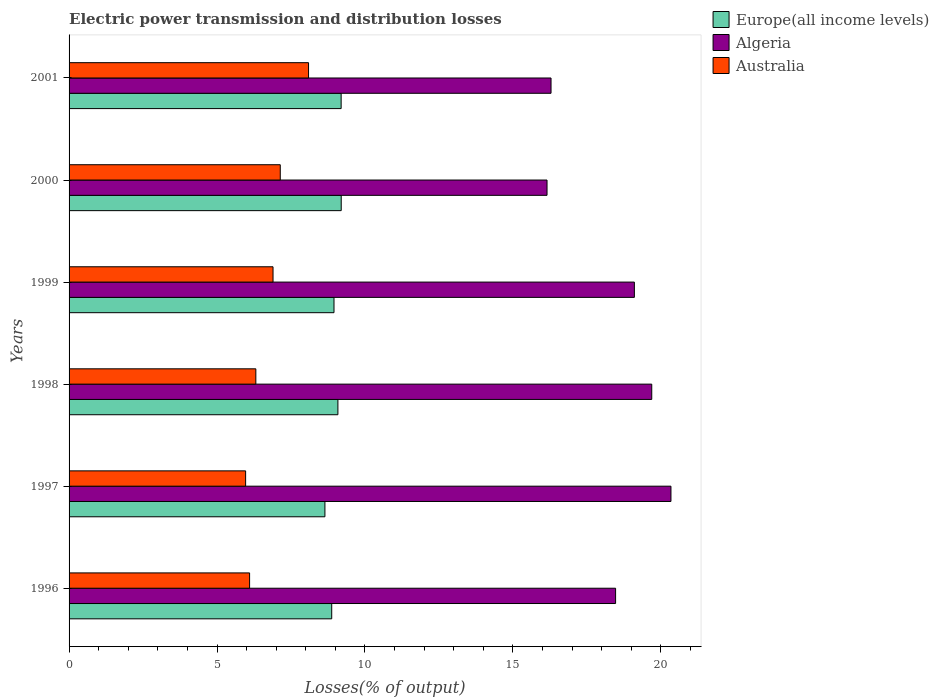How many groups of bars are there?
Make the answer very short. 6. Are the number of bars on each tick of the Y-axis equal?
Offer a terse response. Yes. In how many cases, is the number of bars for a given year not equal to the number of legend labels?
Ensure brevity in your answer.  0. What is the electric power transmission and distribution losses in Algeria in 1997?
Keep it short and to the point. 20.34. Across all years, what is the maximum electric power transmission and distribution losses in Australia?
Your answer should be very brief. 8.09. Across all years, what is the minimum electric power transmission and distribution losses in Australia?
Offer a terse response. 5.97. In which year was the electric power transmission and distribution losses in Algeria minimum?
Your answer should be compact. 2000. What is the total electric power transmission and distribution losses in Australia in the graph?
Ensure brevity in your answer.  40.51. What is the difference between the electric power transmission and distribution losses in Algeria in 1996 and that in 1998?
Give a very brief answer. -1.22. What is the difference between the electric power transmission and distribution losses in Europe(all income levels) in 1997 and the electric power transmission and distribution losses in Australia in 1999?
Your response must be concise. 1.75. What is the average electric power transmission and distribution losses in Europe(all income levels) per year?
Your response must be concise. 8.99. In the year 2000, what is the difference between the electric power transmission and distribution losses in Algeria and electric power transmission and distribution losses in Europe(all income levels)?
Ensure brevity in your answer.  6.96. What is the ratio of the electric power transmission and distribution losses in Algeria in 1998 to that in 2000?
Offer a terse response. 1.22. Is the electric power transmission and distribution losses in Australia in 1997 less than that in 2001?
Make the answer very short. Yes. What is the difference between the highest and the second highest electric power transmission and distribution losses in Algeria?
Your response must be concise. 0.65. What is the difference between the highest and the lowest electric power transmission and distribution losses in Australia?
Your response must be concise. 2.13. In how many years, is the electric power transmission and distribution losses in Europe(all income levels) greater than the average electric power transmission and distribution losses in Europe(all income levels) taken over all years?
Offer a terse response. 3. Is the sum of the electric power transmission and distribution losses in Europe(all income levels) in 1998 and 2001 greater than the maximum electric power transmission and distribution losses in Australia across all years?
Keep it short and to the point. Yes. What does the 1st bar from the top in 1999 represents?
Your response must be concise. Australia. What does the 1st bar from the bottom in 1999 represents?
Keep it short and to the point. Europe(all income levels). Is it the case that in every year, the sum of the electric power transmission and distribution losses in Algeria and electric power transmission and distribution losses in Australia is greater than the electric power transmission and distribution losses in Europe(all income levels)?
Make the answer very short. Yes. How many years are there in the graph?
Ensure brevity in your answer.  6. Does the graph contain grids?
Keep it short and to the point. No. Where does the legend appear in the graph?
Give a very brief answer. Top right. How many legend labels are there?
Keep it short and to the point. 3. How are the legend labels stacked?
Make the answer very short. Vertical. What is the title of the graph?
Offer a terse response. Electric power transmission and distribution losses. What is the label or title of the X-axis?
Ensure brevity in your answer.  Losses(% of output). What is the label or title of the Y-axis?
Your answer should be very brief. Years. What is the Losses(% of output) of Europe(all income levels) in 1996?
Make the answer very short. 8.88. What is the Losses(% of output) of Algeria in 1996?
Ensure brevity in your answer.  18.47. What is the Losses(% of output) in Australia in 1996?
Your answer should be very brief. 6.1. What is the Losses(% of output) in Europe(all income levels) in 1997?
Offer a very short reply. 8.65. What is the Losses(% of output) of Algeria in 1997?
Keep it short and to the point. 20.34. What is the Losses(% of output) in Australia in 1997?
Keep it short and to the point. 5.97. What is the Losses(% of output) of Europe(all income levels) in 1998?
Ensure brevity in your answer.  9.09. What is the Losses(% of output) of Algeria in 1998?
Keep it short and to the point. 19.69. What is the Losses(% of output) in Australia in 1998?
Provide a short and direct response. 6.31. What is the Losses(% of output) of Europe(all income levels) in 1999?
Make the answer very short. 8.95. What is the Losses(% of output) in Algeria in 1999?
Your response must be concise. 19.11. What is the Losses(% of output) in Australia in 1999?
Give a very brief answer. 6.89. What is the Losses(% of output) of Europe(all income levels) in 2000?
Give a very brief answer. 9.2. What is the Losses(% of output) in Algeria in 2000?
Offer a very short reply. 16.15. What is the Losses(% of output) of Australia in 2000?
Your answer should be compact. 7.14. What is the Losses(% of output) in Europe(all income levels) in 2001?
Offer a very short reply. 9.2. What is the Losses(% of output) in Algeria in 2001?
Keep it short and to the point. 16.29. What is the Losses(% of output) of Australia in 2001?
Your answer should be very brief. 8.09. Across all years, what is the maximum Losses(% of output) in Europe(all income levels)?
Your answer should be compact. 9.2. Across all years, what is the maximum Losses(% of output) of Algeria?
Offer a terse response. 20.34. Across all years, what is the maximum Losses(% of output) of Australia?
Provide a succinct answer. 8.09. Across all years, what is the minimum Losses(% of output) of Europe(all income levels)?
Your answer should be compact. 8.65. Across all years, what is the minimum Losses(% of output) of Algeria?
Make the answer very short. 16.15. Across all years, what is the minimum Losses(% of output) of Australia?
Your answer should be very brief. 5.97. What is the total Losses(% of output) in Europe(all income levels) in the graph?
Offer a very short reply. 53.96. What is the total Losses(% of output) of Algeria in the graph?
Offer a very short reply. 110.06. What is the total Losses(% of output) in Australia in the graph?
Keep it short and to the point. 40.51. What is the difference between the Losses(% of output) of Europe(all income levels) in 1996 and that in 1997?
Your answer should be very brief. 0.23. What is the difference between the Losses(% of output) in Algeria in 1996 and that in 1997?
Provide a short and direct response. -1.87. What is the difference between the Losses(% of output) of Australia in 1996 and that in 1997?
Your answer should be very brief. 0.13. What is the difference between the Losses(% of output) in Europe(all income levels) in 1996 and that in 1998?
Offer a very short reply. -0.21. What is the difference between the Losses(% of output) of Algeria in 1996 and that in 1998?
Your answer should be compact. -1.22. What is the difference between the Losses(% of output) in Australia in 1996 and that in 1998?
Offer a terse response. -0.21. What is the difference between the Losses(% of output) in Europe(all income levels) in 1996 and that in 1999?
Offer a very short reply. -0.08. What is the difference between the Losses(% of output) of Algeria in 1996 and that in 1999?
Offer a terse response. -0.63. What is the difference between the Losses(% of output) of Australia in 1996 and that in 1999?
Give a very brief answer. -0.79. What is the difference between the Losses(% of output) of Europe(all income levels) in 1996 and that in 2000?
Your answer should be compact. -0.32. What is the difference between the Losses(% of output) in Algeria in 1996 and that in 2000?
Your response must be concise. 2.32. What is the difference between the Losses(% of output) in Australia in 1996 and that in 2000?
Your answer should be very brief. -1.04. What is the difference between the Losses(% of output) in Europe(all income levels) in 1996 and that in 2001?
Your answer should be very brief. -0.32. What is the difference between the Losses(% of output) of Algeria in 1996 and that in 2001?
Offer a terse response. 2.18. What is the difference between the Losses(% of output) in Australia in 1996 and that in 2001?
Make the answer very short. -1.99. What is the difference between the Losses(% of output) in Europe(all income levels) in 1997 and that in 1998?
Your response must be concise. -0.44. What is the difference between the Losses(% of output) in Algeria in 1997 and that in 1998?
Ensure brevity in your answer.  0.65. What is the difference between the Losses(% of output) in Australia in 1997 and that in 1998?
Give a very brief answer. -0.35. What is the difference between the Losses(% of output) in Europe(all income levels) in 1997 and that in 1999?
Provide a short and direct response. -0.31. What is the difference between the Losses(% of output) in Algeria in 1997 and that in 1999?
Make the answer very short. 1.24. What is the difference between the Losses(% of output) in Australia in 1997 and that in 1999?
Offer a very short reply. -0.93. What is the difference between the Losses(% of output) in Europe(all income levels) in 1997 and that in 2000?
Provide a short and direct response. -0.55. What is the difference between the Losses(% of output) in Algeria in 1997 and that in 2000?
Your answer should be very brief. 4.19. What is the difference between the Losses(% of output) of Australia in 1997 and that in 2000?
Give a very brief answer. -1.17. What is the difference between the Losses(% of output) in Europe(all income levels) in 1997 and that in 2001?
Offer a terse response. -0.55. What is the difference between the Losses(% of output) of Algeria in 1997 and that in 2001?
Give a very brief answer. 4.05. What is the difference between the Losses(% of output) of Australia in 1997 and that in 2001?
Offer a very short reply. -2.13. What is the difference between the Losses(% of output) in Europe(all income levels) in 1998 and that in 1999?
Offer a terse response. 0.13. What is the difference between the Losses(% of output) of Algeria in 1998 and that in 1999?
Ensure brevity in your answer.  0.59. What is the difference between the Losses(% of output) in Australia in 1998 and that in 1999?
Give a very brief answer. -0.58. What is the difference between the Losses(% of output) in Europe(all income levels) in 1998 and that in 2000?
Provide a short and direct response. -0.11. What is the difference between the Losses(% of output) in Algeria in 1998 and that in 2000?
Your answer should be compact. 3.54. What is the difference between the Losses(% of output) of Australia in 1998 and that in 2000?
Ensure brevity in your answer.  -0.83. What is the difference between the Losses(% of output) of Europe(all income levels) in 1998 and that in 2001?
Provide a short and direct response. -0.11. What is the difference between the Losses(% of output) in Algeria in 1998 and that in 2001?
Give a very brief answer. 3.4. What is the difference between the Losses(% of output) in Australia in 1998 and that in 2001?
Provide a succinct answer. -1.78. What is the difference between the Losses(% of output) of Europe(all income levels) in 1999 and that in 2000?
Your answer should be compact. -0.24. What is the difference between the Losses(% of output) in Algeria in 1999 and that in 2000?
Make the answer very short. 2.95. What is the difference between the Losses(% of output) of Australia in 1999 and that in 2000?
Ensure brevity in your answer.  -0.24. What is the difference between the Losses(% of output) in Europe(all income levels) in 1999 and that in 2001?
Ensure brevity in your answer.  -0.24. What is the difference between the Losses(% of output) of Algeria in 1999 and that in 2001?
Make the answer very short. 2.82. What is the difference between the Losses(% of output) of Australia in 1999 and that in 2001?
Provide a short and direct response. -1.2. What is the difference between the Losses(% of output) of Europe(all income levels) in 2000 and that in 2001?
Provide a succinct answer. 0. What is the difference between the Losses(% of output) of Algeria in 2000 and that in 2001?
Provide a short and direct response. -0.14. What is the difference between the Losses(% of output) in Australia in 2000 and that in 2001?
Provide a short and direct response. -0.96. What is the difference between the Losses(% of output) in Europe(all income levels) in 1996 and the Losses(% of output) in Algeria in 1997?
Provide a succinct answer. -11.47. What is the difference between the Losses(% of output) in Europe(all income levels) in 1996 and the Losses(% of output) in Australia in 1997?
Provide a succinct answer. 2.91. What is the difference between the Losses(% of output) of Algeria in 1996 and the Losses(% of output) of Australia in 1997?
Provide a succinct answer. 12.5. What is the difference between the Losses(% of output) in Europe(all income levels) in 1996 and the Losses(% of output) in Algeria in 1998?
Offer a terse response. -10.82. What is the difference between the Losses(% of output) in Europe(all income levels) in 1996 and the Losses(% of output) in Australia in 1998?
Offer a terse response. 2.56. What is the difference between the Losses(% of output) in Algeria in 1996 and the Losses(% of output) in Australia in 1998?
Offer a terse response. 12.16. What is the difference between the Losses(% of output) in Europe(all income levels) in 1996 and the Losses(% of output) in Algeria in 1999?
Ensure brevity in your answer.  -10.23. What is the difference between the Losses(% of output) of Europe(all income levels) in 1996 and the Losses(% of output) of Australia in 1999?
Ensure brevity in your answer.  1.98. What is the difference between the Losses(% of output) in Algeria in 1996 and the Losses(% of output) in Australia in 1999?
Provide a short and direct response. 11.58. What is the difference between the Losses(% of output) in Europe(all income levels) in 1996 and the Losses(% of output) in Algeria in 2000?
Give a very brief answer. -7.28. What is the difference between the Losses(% of output) in Europe(all income levels) in 1996 and the Losses(% of output) in Australia in 2000?
Give a very brief answer. 1.74. What is the difference between the Losses(% of output) of Algeria in 1996 and the Losses(% of output) of Australia in 2000?
Ensure brevity in your answer.  11.33. What is the difference between the Losses(% of output) in Europe(all income levels) in 1996 and the Losses(% of output) in Algeria in 2001?
Your response must be concise. -7.41. What is the difference between the Losses(% of output) of Europe(all income levels) in 1996 and the Losses(% of output) of Australia in 2001?
Make the answer very short. 0.78. What is the difference between the Losses(% of output) in Algeria in 1996 and the Losses(% of output) in Australia in 2001?
Give a very brief answer. 10.38. What is the difference between the Losses(% of output) of Europe(all income levels) in 1997 and the Losses(% of output) of Algeria in 1998?
Ensure brevity in your answer.  -11.05. What is the difference between the Losses(% of output) of Europe(all income levels) in 1997 and the Losses(% of output) of Australia in 1998?
Keep it short and to the point. 2.33. What is the difference between the Losses(% of output) of Algeria in 1997 and the Losses(% of output) of Australia in 1998?
Provide a succinct answer. 14.03. What is the difference between the Losses(% of output) of Europe(all income levels) in 1997 and the Losses(% of output) of Algeria in 1999?
Make the answer very short. -10.46. What is the difference between the Losses(% of output) in Europe(all income levels) in 1997 and the Losses(% of output) in Australia in 1999?
Give a very brief answer. 1.75. What is the difference between the Losses(% of output) of Algeria in 1997 and the Losses(% of output) of Australia in 1999?
Offer a very short reply. 13.45. What is the difference between the Losses(% of output) of Europe(all income levels) in 1997 and the Losses(% of output) of Algeria in 2000?
Your response must be concise. -7.51. What is the difference between the Losses(% of output) of Europe(all income levels) in 1997 and the Losses(% of output) of Australia in 2000?
Provide a succinct answer. 1.51. What is the difference between the Losses(% of output) in Algeria in 1997 and the Losses(% of output) in Australia in 2000?
Ensure brevity in your answer.  13.2. What is the difference between the Losses(% of output) of Europe(all income levels) in 1997 and the Losses(% of output) of Algeria in 2001?
Provide a short and direct response. -7.64. What is the difference between the Losses(% of output) in Europe(all income levels) in 1997 and the Losses(% of output) in Australia in 2001?
Provide a succinct answer. 0.55. What is the difference between the Losses(% of output) in Algeria in 1997 and the Losses(% of output) in Australia in 2001?
Your answer should be compact. 12.25. What is the difference between the Losses(% of output) of Europe(all income levels) in 1998 and the Losses(% of output) of Algeria in 1999?
Your answer should be compact. -10.02. What is the difference between the Losses(% of output) of Europe(all income levels) in 1998 and the Losses(% of output) of Australia in 1999?
Keep it short and to the point. 2.19. What is the difference between the Losses(% of output) of Algeria in 1998 and the Losses(% of output) of Australia in 1999?
Provide a succinct answer. 12.8. What is the difference between the Losses(% of output) in Europe(all income levels) in 1998 and the Losses(% of output) in Algeria in 2000?
Keep it short and to the point. -7.07. What is the difference between the Losses(% of output) in Europe(all income levels) in 1998 and the Losses(% of output) in Australia in 2000?
Your response must be concise. 1.95. What is the difference between the Losses(% of output) of Algeria in 1998 and the Losses(% of output) of Australia in 2000?
Offer a very short reply. 12.56. What is the difference between the Losses(% of output) of Europe(all income levels) in 1998 and the Losses(% of output) of Algeria in 2001?
Provide a succinct answer. -7.2. What is the difference between the Losses(% of output) of Algeria in 1998 and the Losses(% of output) of Australia in 2001?
Ensure brevity in your answer.  11.6. What is the difference between the Losses(% of output) of Europe(all income levels) in 1999 and the Losses(% of output) of Algeria in 2000?
Offer a very short reply. -7.2. What is the difference between the Losses(% of output) in Europe(all income levels) in 1999 and the Losses(% of output) in Australia in 2000?
Keep it short and to the point. 1.82. What is the difference between the Losses(% of output) of Algeria in 1999 and the Losses(% of output) of Australia in 2000?
Your answer should be very brief. 11.97. What is the difference between the Losses(% of output) in Europe(all income levels) in 1999 and the Losses(% of output) in Algeria in 2001?
Your response must be concise. -7.34. What is the difference between the Losses(% of output) of Europe(all income levels) in 1999 and the Losses(% of output) of Australia in 2001?
Offer a terse response. 0.86. What is the difference between the Losses(% of output) of Algeria in 1999 and the Losses(% of output) of Australia in 2001?
Keep it short and to the point. 11.01. What is the difference between the Losses(% of output) in Europe(all income levels) in 2000 and the Losses(% of output) in Algeria in 2001?
Offer a very short reply. -7.09. What is the difference between the Losses(% of output) of Europe(all income levels) in 2000 and the Losses(% of output) of Australia in 2001?
Offer a terse response. 1.1. What is the difference between the Losses(% of output) of Algeria in 2000 and the Losses(% of output) of Australia in 2001?
Give a very brief answer. 8.06. What is the average Losses(% of output) of Europe(all income levels) per year?
Make the answer very short. 8.99. What is the average Losses(% of output) in Algeria per year?
Your response must be concise. 18.34. What is the average Losses(% of output) in Australia per year?
Provide a short and direct response. 6.75. In the year 1996, what is the difference between the Losses(% of output) in Europe(all income levels) and Losses(% of output) in Algeria?
Provide a succinct answer. -9.59. In the year 1996, what is the difference between the Losses(% of output) in Europe(all income levels) and Losses(% of output) in Australia?
Make the answer very short. 2.78. In the year 1996, what is the difference between the Losses(% of output) in Algeria and Losses(% of output) in Australia?
Keep it short and to the point. 12.37. In the year 1997, what is the difference between the Losses(% of output) in Europe(all income levels) and Losses(% of output) in Algeria?
Offer a terse response. -11.7. In the year 1997, what is the difference between the Losses(% of output) of Europe(all income levels) and Losses(% of output) of Australia?
Provide a short and direct response. 2.68. In the year 1997, what is the difference between the Losses(% of output) of Algeria and Losses(% of output) of Australia?
Your response must be concise. 14.38. In the year 1998, what is the difference between the Losses(% of output) of Europe(all income levels) and Losses(% of output) of Algeria?
Offer a terse response. -10.61. In the year 1998, what is the difference between the Losses(% of output) in Europe(all income levels) and Losses(% of output) in Australia?
Keep it short and to the point. 2.77. In the year 1998, what is the difference between the Losses(% of output) of Algeria and Losses(% of output) of Australia?
Your response must be concise. 13.38. In the year 1999, what is the difference between the Losses(% of output) of Europe(all income levels) and Losses(% of output) of Algeria?
Your answer should be compact. -10.15. In the year 1999, what is the difference between the Losses(% of output) of Europe(all income levels) and Losses(% of output) of Australia?
Keep it short and to the point. 2.06. In the year 1999, what is the difference between the Losses(% of output) in Algeria and Losses(% of output) in Australia?
Provide a succinct answer. 12.21. In the year 2000, what is the difference between the Losses(% of output) in Europe(all income levels) and Losses(% of output) in Algeria?
Ensure brevity in your answer.  -6.96. In the year 2000, what is the difference between the Losses(% of output) of Europe(all income levels) and Losses(% of output) of Australia?
Offer a terse response. 2.06. In the year 2000, what is the difference between the Losses(% of output) in Algeria and Losses(% of output) in Australia?
Your answer should be very brief. 9.02. In the year 2001, what is the difference between the Losses(% of output) in Europe(all income levels) and Losses(% of output) in Algeria?
Provide a short and direct response. -7.09. In the year 2001, what is the difference between the Losses(% of output) of Europe(all income levels) and Losses(% of output) of Australia?
Your answer should be compact. 1.1. In the year 2001, what is the difference between the Losses(% of output) in Algeria and Losses(% of output) in Australia?
Make the answer very short. 8.2. What is the ratio of the Losses(% of output) of Europe(all income levels) in 1996 to that in 1997?
Provide a succinct answer. 1.03. What is the ratio of the Losses(% of output) in Algeria in 1996 to that in 1997?
Make the answer very short. 0.91. What is the ratio of the Losses(% of output) in Australia in 1996 to that in 1997?
Provide a short and direct response. 1.02. What is the ratio of the Losses(% of output) of Europe(all income levels) in 1996 to that in 1998?
Ensure brevity in your answer.  0.98. What is the ratio of the Losses(% of output) of Algeria in 1996 to that in 1998?
Give a very brief answer. 0.94. What is the ratio of the Losses(% of output) in Australia in 1996 to that in 1998?
Provide a short and direct response. 0.97. What is the ratio of the Losses(% of output) in Europe(all income levels) in 1996 to that in 1999?
Offer a terse response. 0.99. What is the ratio of the Losses(% of output) in Algeria in 1996 to that in 1999?
Keep it short and to the point. 0.97. What is the ratio of the Losses(% of output) of Australia in 1996 to that in 1999?
Your answer should be very brief. 0.89. What is the ratio of the Losses(% of output) in Europe(all income levels) in 1996 to that in 2000?
Your answer should be very brief. 0.97. What is the ratio of the Losses(% of output) in Algeria in 1996 to that in 2000?
Your answer should be compact. 1.14. What is the ratio of the Losses(% of output) of Australia in 1996 to that in 2000?
Your answer should be very brief. 0.85. What is the ratio of the Losses(% of output) of Europe(all income levels) in 1996 to that in 2001?
Your answer should be very brief. 0.97. What is the ratio of the Losses(% of output) of Algeria in 1996 to that in 2001?
Your response must be concise. 1.13. What is the ratio of the Losses(% of output) of Australia in 1996 to that in 2001?
Give a very brief answer. 0.75. What is the ratio of the Losses(% of output) in Europe(all income levels) in 1997 to that in 1998?
Make the answer very short. 0.95. What is the ratio of the Losses(% of output) of Algeria in 1997 to that in 1998?
Provide a succinct answer. 1.03. What is the ratio of the Losses(% of output) of Australia in 1997 to that in 1998?
Make the answer very short. 0.95. What is the ratio of the Losses(% of output) of Europe(all income levels) in 1997 to that in 1999?
Give a very brief answer. 0.97. What is the ratio of the Losses(% of output) in Algeria in 1997 to that in 1999?
Provide a short and direct response. 1.06. What is the ratio of the Losses(% of output) in Australia in 1997 to that in 1999?
Offer a very short reply. 0.87. What is the ratio of the Losses(% of output) in Europe(all income levels) in 1997 to that in 2000?
Your answer should be very brief. 0.94. What is the ratio of the Losses(% of output) in Algeria in 1997 to that in 2000?
Provide a succinct answer. 1.26. What is the ratio of the Losses(% of output) in Australia in 1997 to that in 2000?
Your response must be concise. 0.84. What is the ratio of the Losses(% of output) in Europe(all income levels) in 1997 to that in 2001?
Ensure brevity in your answer.  0.94. What is the ratio of the Losses(% of output) of Algeria in 1997 to that in 2001?
Give a very brief answer. 1.25. What is the ratio of the Losses(% of output) in Australia in 1997 to that in 2001?
Offer a terse response. 0.74. What is the ratio of the Losses(% of output) in Europe(all income levels) in 1998 to that in 1999?
Your answer should be compact. 1.01. What is the ratio of the Losses(% of output) of Algeria in 1998 to that in 1999?
Give a very brief answer. 1.03. What is the ratio of the Losses(% of output) in Australia in 1998 to that in 1999?
Your answer should be compact. 0.92. What is the ratio of the Losses(% of output) of Algeria in 1998 to that in 2000?
Offer a terse response. 1.22. What is the ratio of the Losses(% of output) in Australia in 1998 to that in 2000?
Make the answer very short. 0.88. What is the ratio of the Losses(% of output) in Algeria in 1998 to that in 2001?
Keep it short and to the point. 1.21. What is the ratio of the Losses(% of output) of Australia in 1998 to that in 2001?
Provide a short and direct response. 0.78. What is the ratio of the Losses(% of output) in Europe(all income levels) in 1999 to that in 2000?
Ensure brevity in your answer.  0.97. What is the ratio of the Losses(% of output) of Algeria in 1999 to that in 2000?
Provide a short and direct response. 1.18. What is the ratio of the Losses(% of output) of Australia in 1999 to that in 2000?
Offer a very short reply. 0.97. What is the ratio of the Losses(% of output) of Europe(all income levels) in 1999 to that in 2001?
Your answer should be compact. 0.97. What is the ratio of the Losses(% of output) of Algeria in 1999 to that in 2001?
Keep it short and to the point. 1.17. What is the ratio of the Losses(% of output) in Australia in 1999 to that in 2001?
Keep it short and to the point. 0.85. What is the ratio of the Losses(% of output) of Europe(all income levels) in 2000 to that in 2001?
Your response must be concise. 1. What is the ratio of the Losses(% of output) in Australia in 2000 to that in 2001?
Provide a succinct answer. 0.88. What is the difference between the highest and the second highest Losses(% of output) in Europe(all income levels)?
Keep it short and to the point. 0. What is the difference between the highest and the second highest Losses(% of output) in Algeria?
Provide a succinct answer. 0.65. What is the difference between the highest and the second highest Losses(% of output) of Australia?
Make the answer very short. 0.96. What is the difference between the highest and the lowest Losses(% of output) of Europe(all income levels)?
Make the answer very short. 0.55. What is the difference between the highest and the lowest Losses(% of output) in Algeria?
Keep it short and to the point. 4.19. What is the difference between the highest and the lowest Losses(% of output) of Australia?
Offer a terse response. 2.13. 